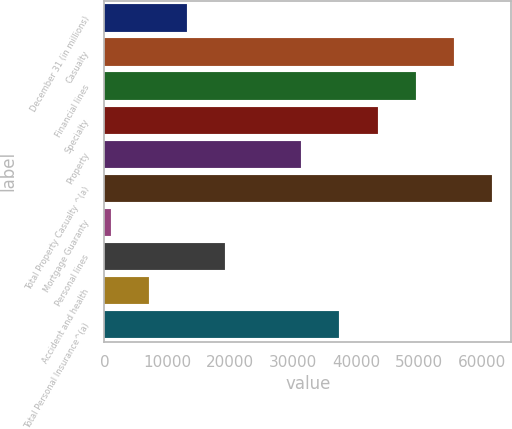<chart> <loc_0><loc_0><loc_500><loc_500><bar_chart><fcel>December 31 (in millions)<fcel>Casualty<fcel>Financial lines<fcel>Specialty<fcel>Property<fcel>Total Property Casualty ^(a)<fcel>Mortgage Guaranty<fcel>Personal lines<fcel>Accident and health<fcel>Total Personal Insurance^(a)<nl><fcel>13104<fcel>55548.5<fcel>49485<fcel>43421.5<fcel>31294.5<fcel>61612<fcel>977<fcel>19167.5<fcel>7040.5<fcel>37358<nl></chart> 